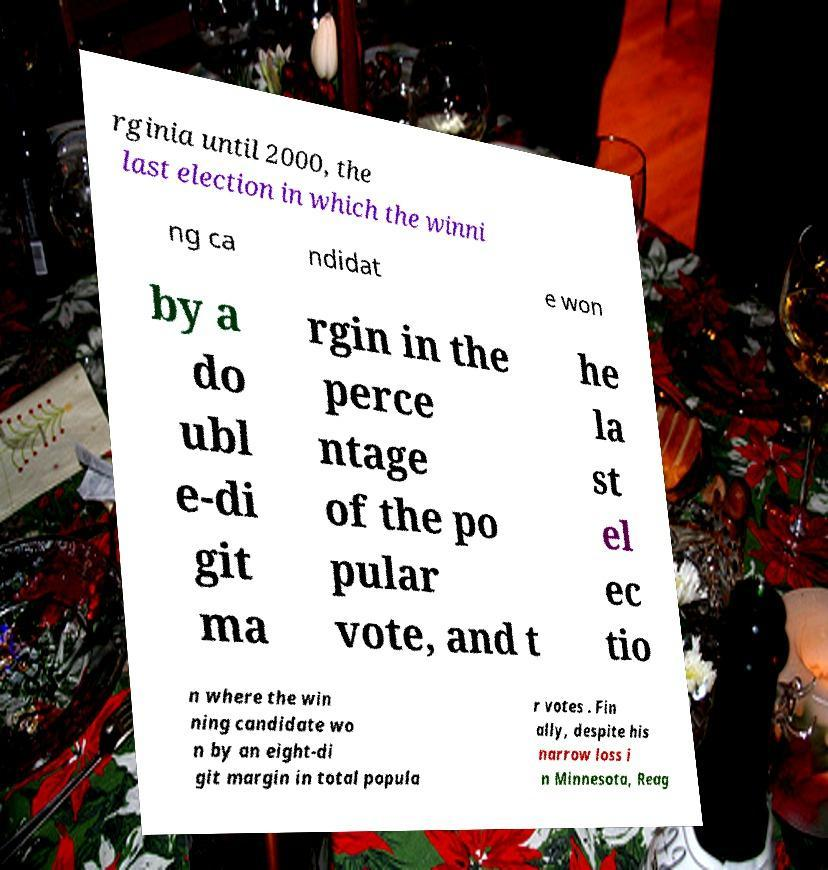There's text embedded in this image that I need extracted. Can you transcribe it verbatim? rginia until 2000, the last election in which the winni ng ca ndidat e won by a do ubl e-di git ma rgin in the perce ntage of the po pular vote, and t he la st el ec tio n where the win ning candidate wo n by an eight-di git margin in total popula r votes . Fin ally, despite his narrow loss i n Minnesota, Reag 